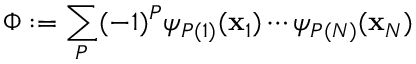<formula> <loc_0><loc_0><loc_500><loc_500>\Phi \colon = \sum _ { P } ( - 1 ) ^ { P } \psi _ { P ( 1 ) } ( x _ { 1 } ) \cdots \psi _ { P ( N ) } ( x _ { N } )</formula> 